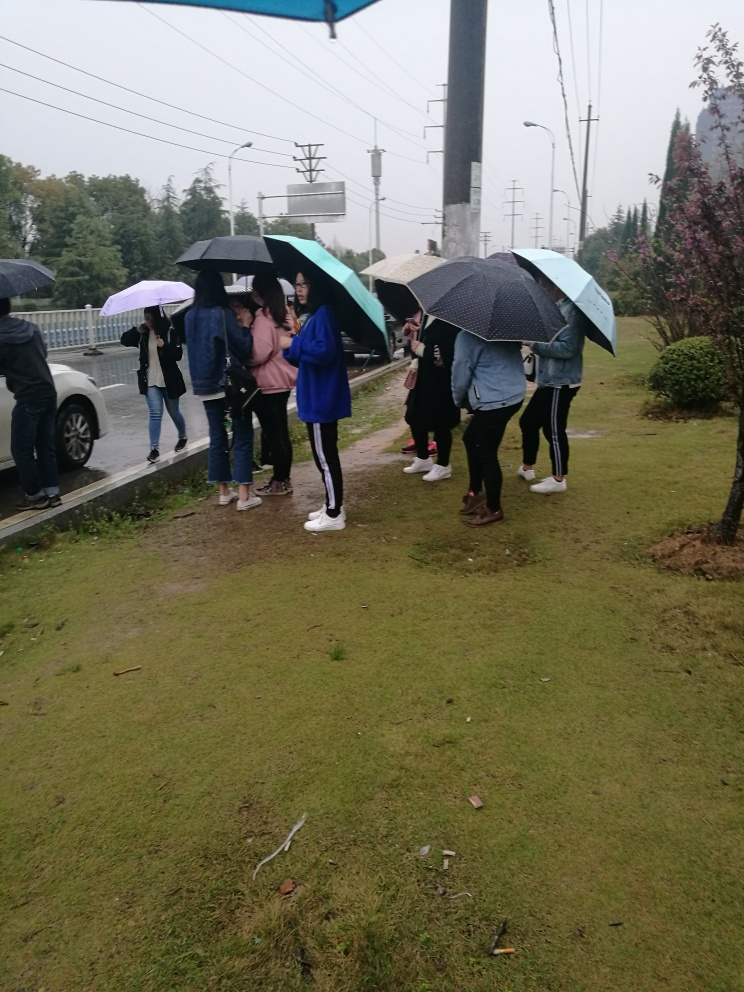The environment seems wet; how does this impact the mood of the scene? The wet conditions and the group holding umbrellas create a sense of camaraderie amongst the individuals as they share the experience of the weather. Despite the gray skies and damp surroundings, the scene might evoke a feeling of communal resilience or a shared understanding that inclement weather is just a part of life. 